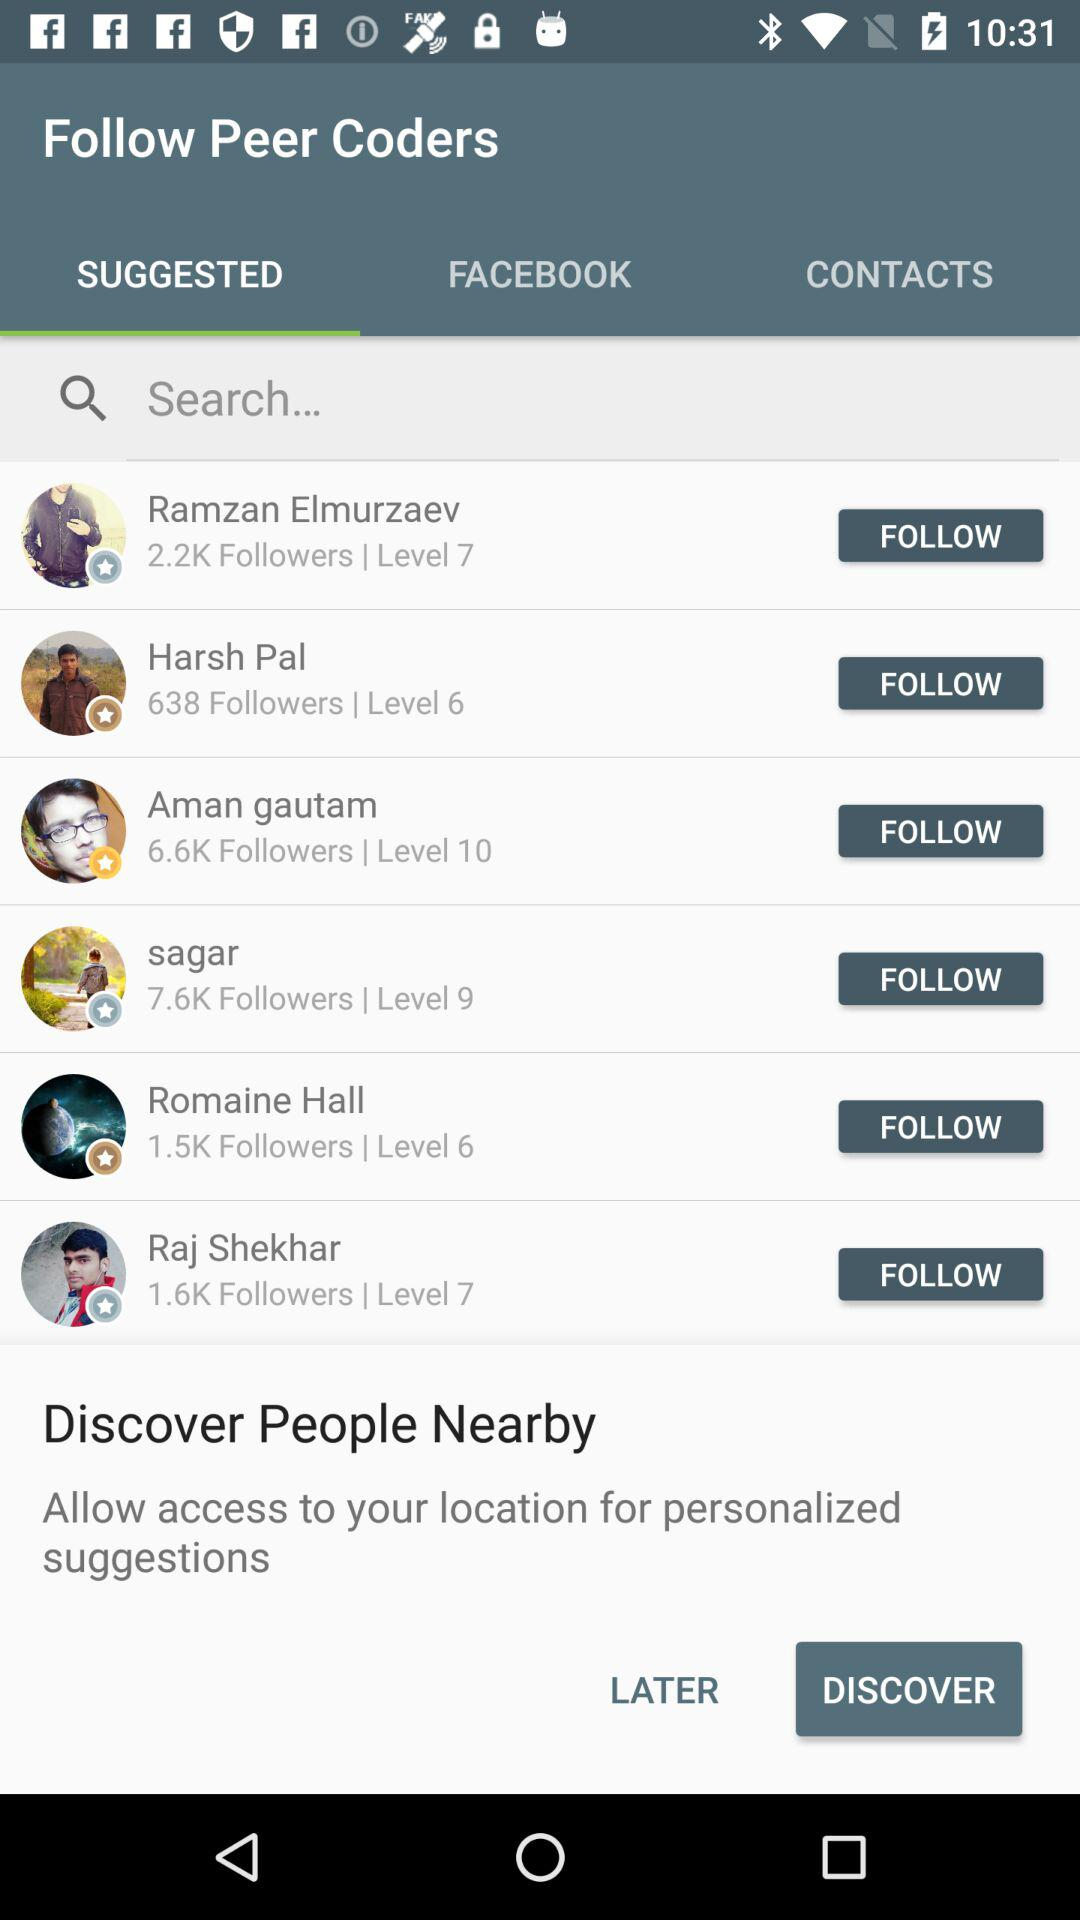How many followers does Aman gautam have?
Answer the question using a single word or phrase. 6.6K 